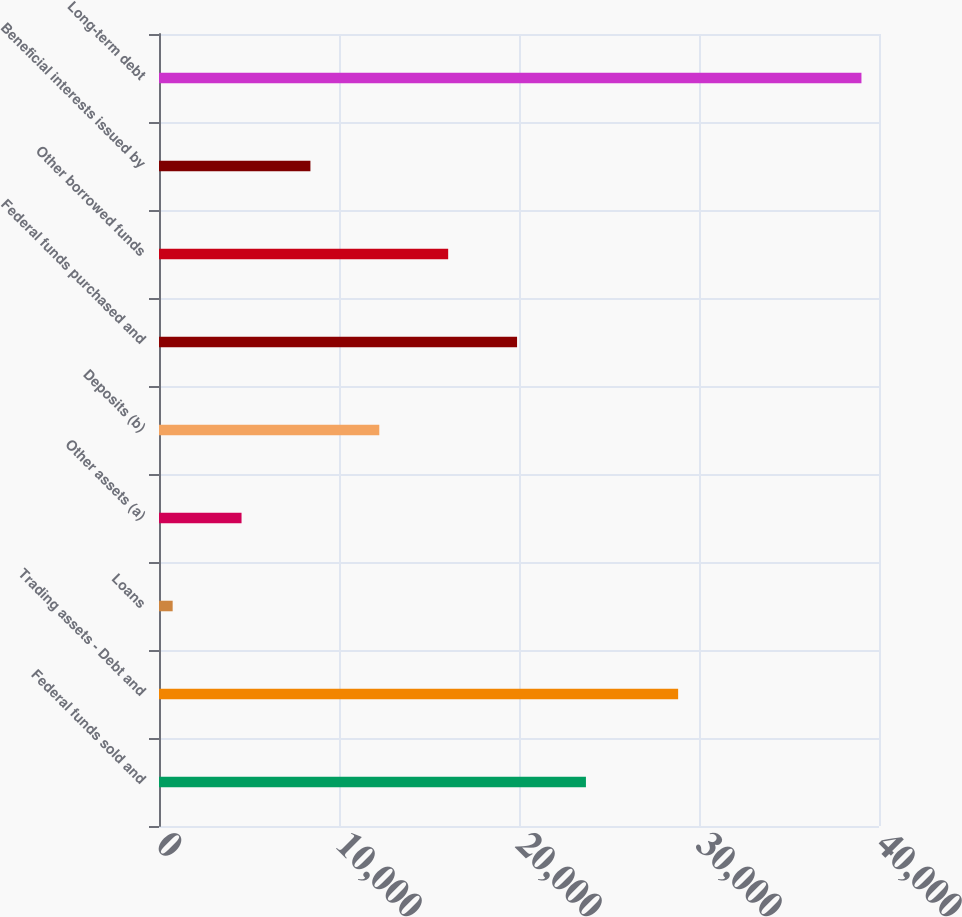Convert chart. <chart><loc_0><loc_0><loc_500><loc_500><bar_chart><fcel>Federal funds sold and<fcel>Trading assets - Debt and<fcel>Loans<fcel>Other assets (a)<fcel>Deposits (b)<fcel>Federal funds purchased and<fcel>Other borrowed funds<fcel>Beneficial interests issued by<fcel>Long-term debt<nl><fcel>23718.6<fcel>28841<fcel>759<fcel>4585.6<fcel>12238.8<fcel>19892<fcel>16065.4<fcel>8412.2<fcel>39025<nl></chart> 